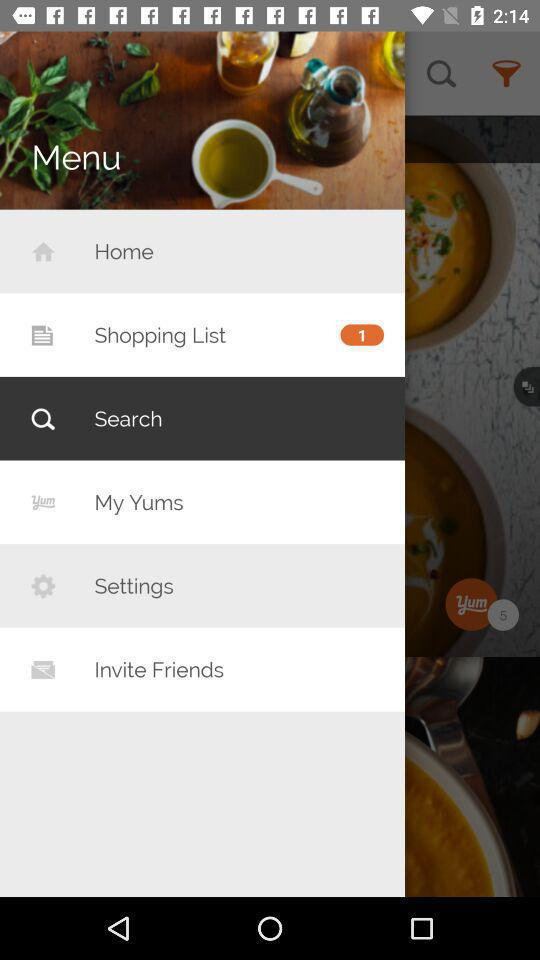How many items are there in the shopping list? There is 1 item in the shopping list. 